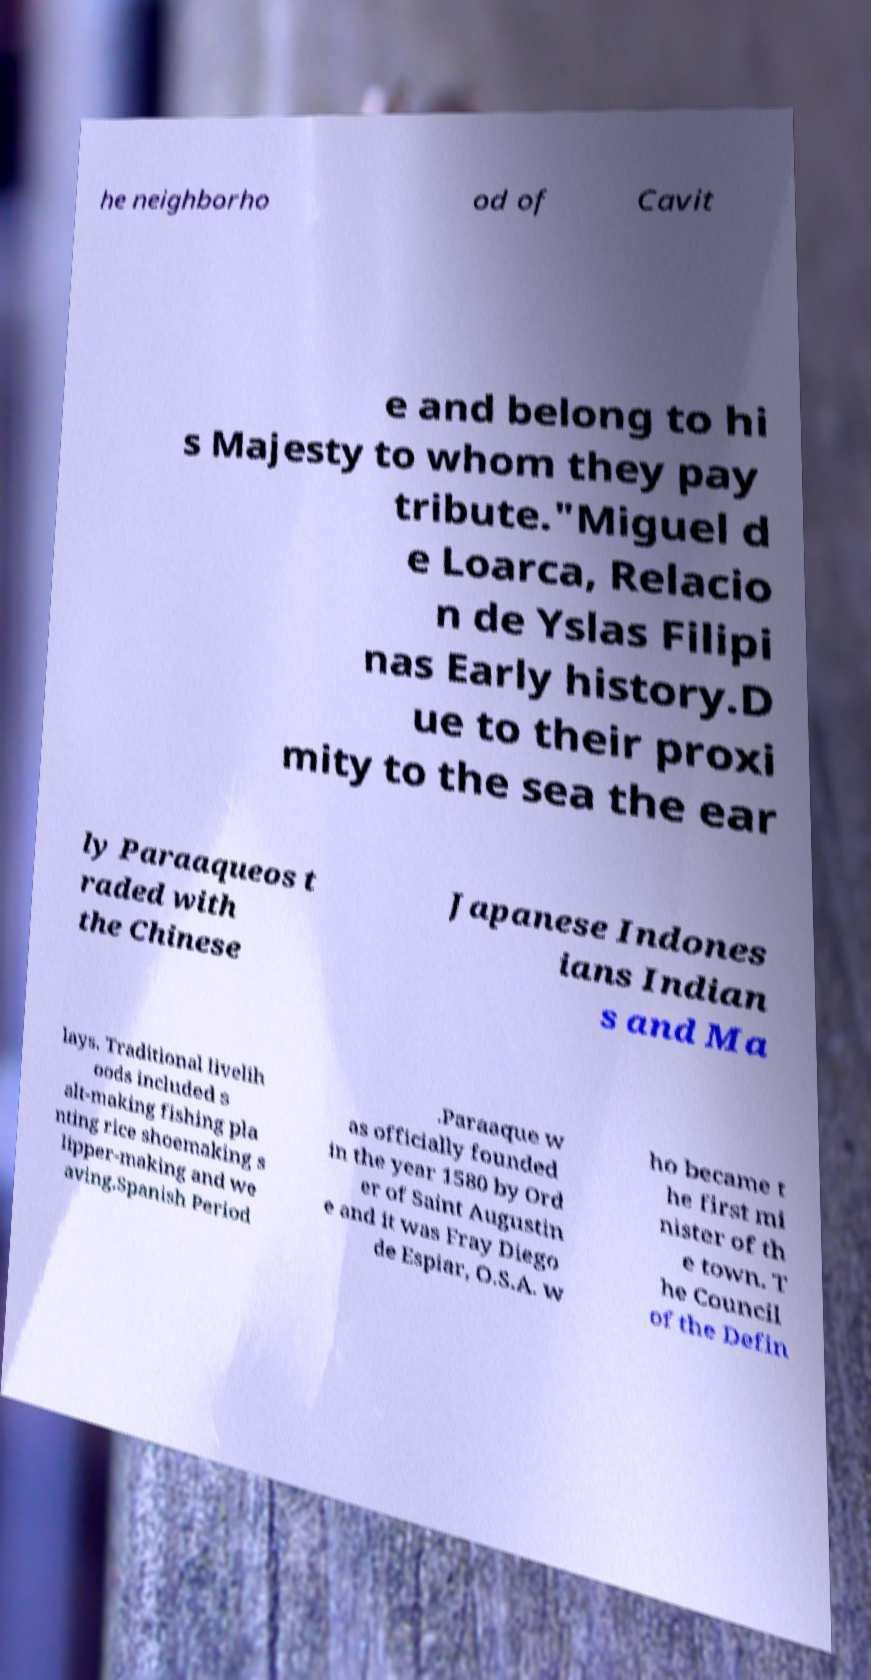Can you accurately transcribe the text from the provided image for me? he neighborho od of Cavit e and belong to hi s Majesty to whom they pay tribute."Miguel d e Loarca, Relacio n de Yslas Filipi nas Early history.D ue to their proxi mity to the sea the ear ly Paraaqueos t raded with the Chinese Japanese Indones ians Indian s and Ma lays. Traditional livelih oods included s alt-making fishing pla nting rice shoemaking s lipper-making and we aving.Spanish Period .Paraaque w as officially founded in the year 1580 by Ord er of Saint Augustin e and it was Fray Diego de Espiar, O.S.A. w ho became t he first mi nister of th e town. T he Council of the Defin 